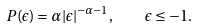Convert formula to latex. <formula><loc_0><loc_0><loc_500><loc_500>P ( \epsilon ) = \alpha | \epsilon | ^ { - \alpha - 1 } , \quad \epsilon \leq - 1 .</formula> 